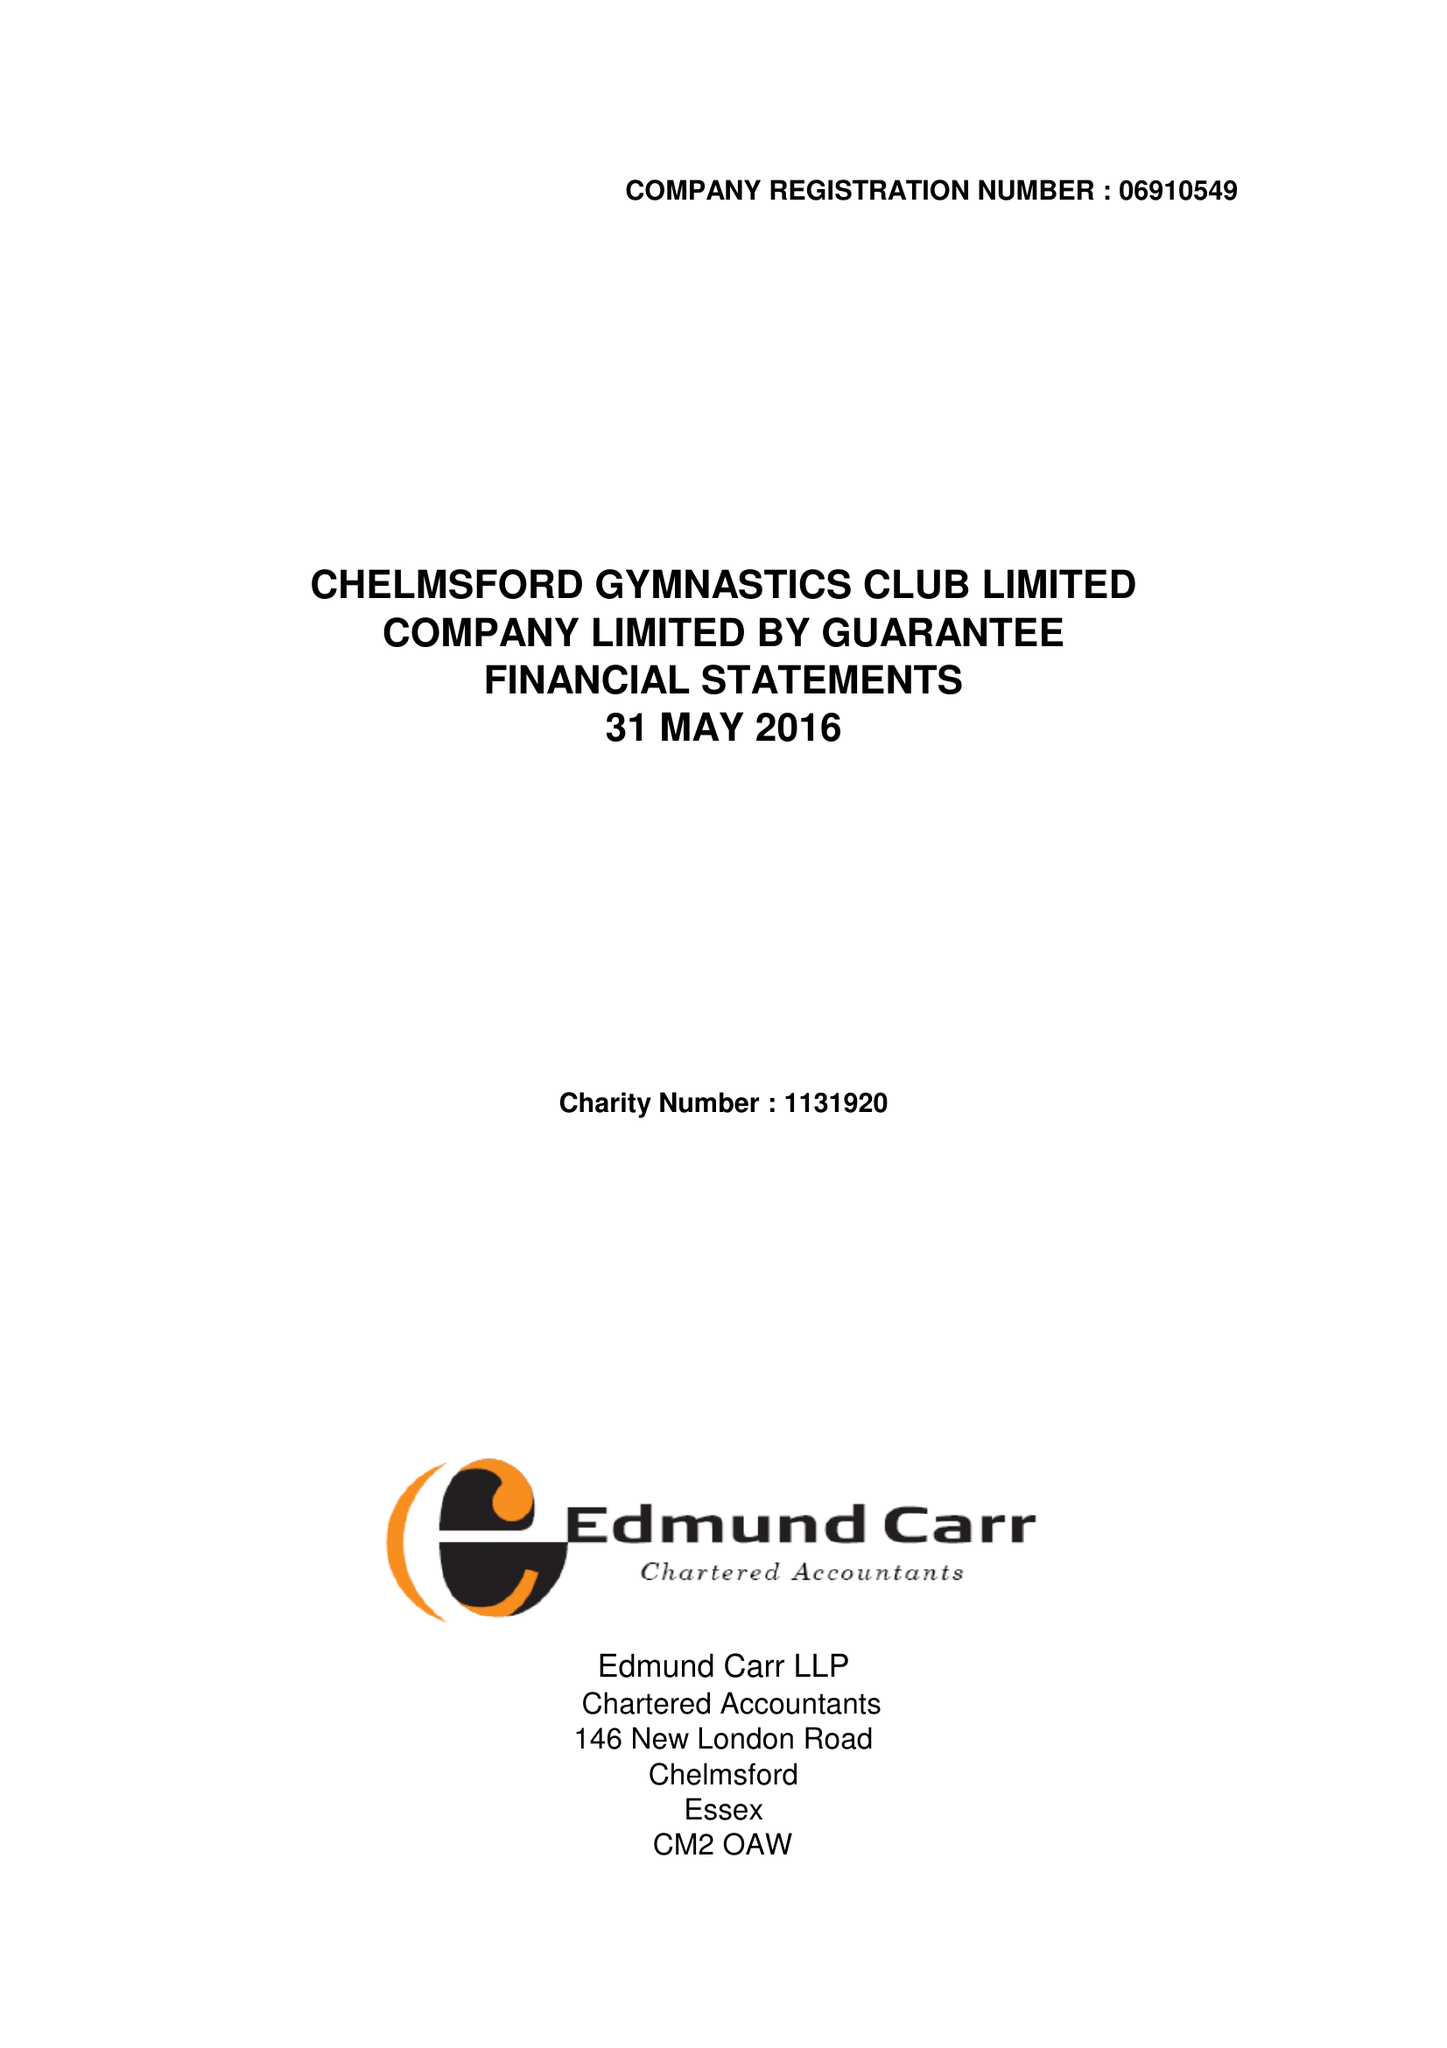What is the value for the address__street_line?
Answer the question using a single word or phrase. 9 THE HEYTHROP 